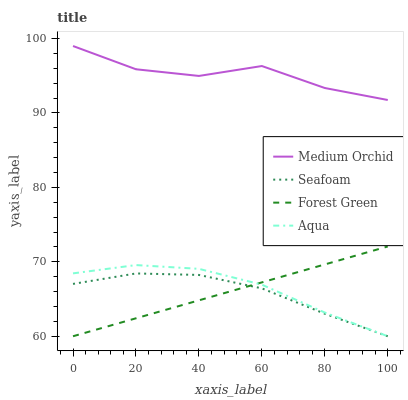Does Seafoam have the minimum area under the curve?
Answer yes or no. Yes. Does Medium Orchid have the maximum area under the curve?
Answer yes or no. Yes. Does Aqua have the minimum area under the curve?
Answer yes or no. No. Does Aqua have the maximum area under the curve?
Answer yes or no. No. Is Forest Green the smoothest?
Answer yes or no. Yes. Is Medium Orchid the roughest?
Answer yes or no. Yes. Is Aqua the smoothest?
Answer yes or no. No. Is Aqua the roughest?
Answer yes or no. No. Does Forest Green have the lowest value?
Answer yes or no. Yes. Does Medium Orchid have the lowest value?
Answer yes or no. No. Does Medium Orchid have the highest value?
Answer yes or no. Yes. Does Aqua have the highest value?
Answer yes or no. No. Is Seafoam less than Medium Orchid?
Answer yes or no. Yes. Is Medium Orchid greater than Seafoam?
Answer yes or no. Yes. Does Aqua intersect Forest Green?
Answer yes or no. Yes. Is Aqua less than Forest Green?
Answer yes or no. No. Is Aqua greater than Forest Green?
Answer yes or no. No. Does Seafoam intersect Medium Orchid?
Answer yes or no. No. 